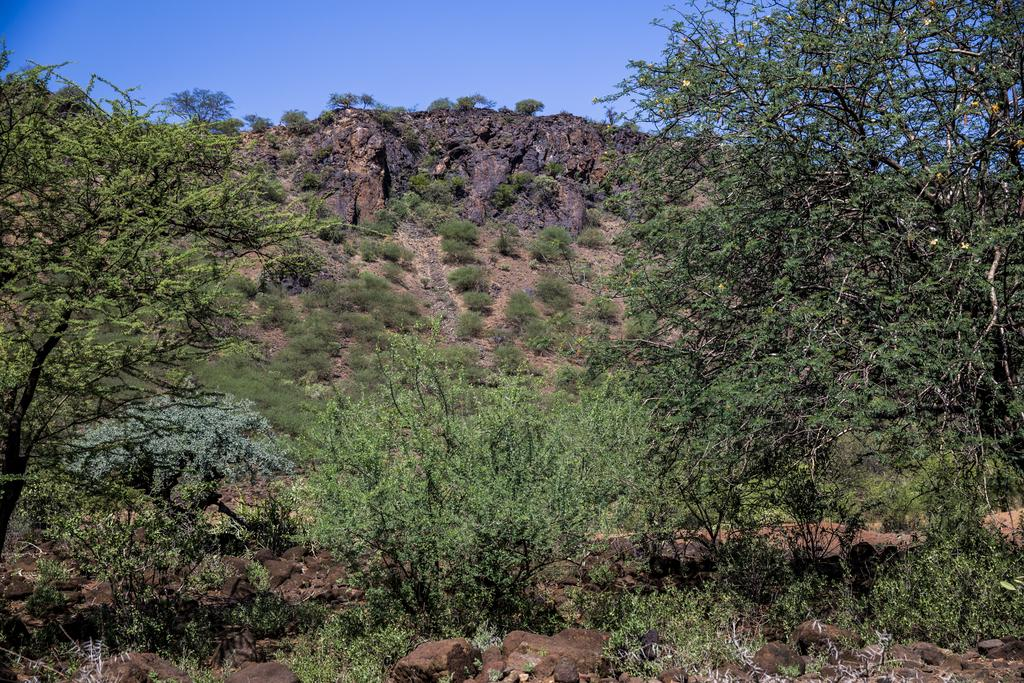What type of vegetation can be seen in the image? There is a group of plants and trees in the image. What else can be seen on the hill in the image? There are stones on a hill in the image. What is visible in the background of the image? The sky is visible in the image. How would you describe the weather based on the appearance of the sky? The sky looks cloudy in the image. Can you tell me how many times the calendar is mentioned in the image? There is no mention of a calendar in the image. Is there a gun visible in the image? There is no gun present in the image. 